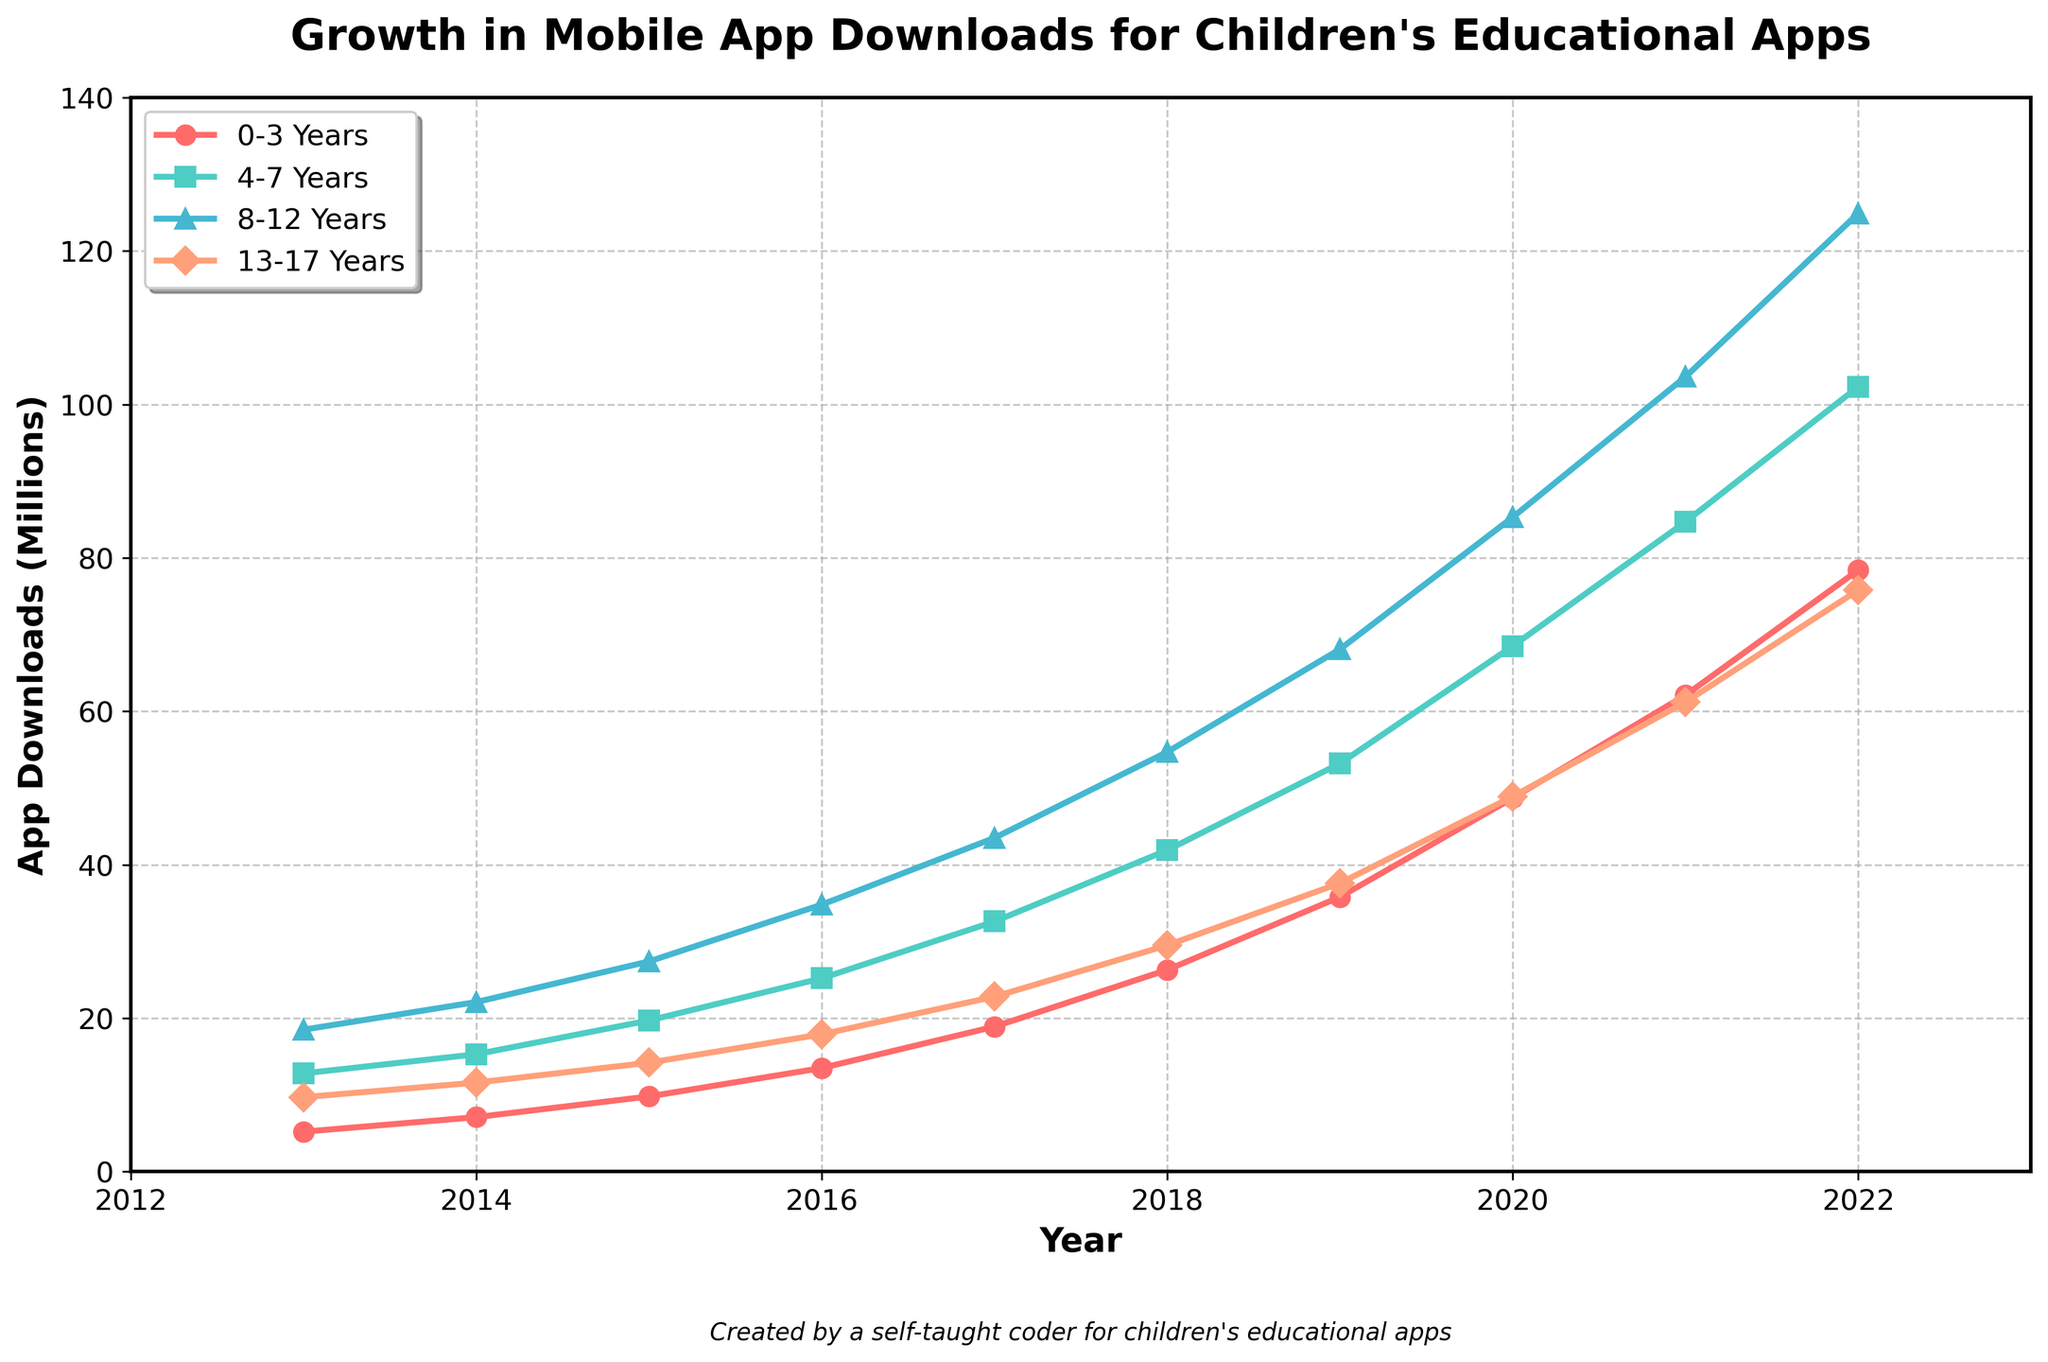What's the total download count for the 0-3 years age group across the years? To find the total download count for the 0-3 years age group, sum the values for each year: 5.2 + 7.1 + 9.8 + 13.5 + 18.9 + 26.3 + 35.8 + 48.7 + 62.1 + 78.4 = 305.8 million
Answer: 305.8 million In which year did the 8-12 years age group surpass 50 million downloads? Check the values for the 8-12 years age group until you find the year where the count first exceeds 50 million. In 2018, the downloads are 54.7 million.
Answer: 2018 Which age group had the highest number of downloads in 2016? Compare the download values for all age groups in 2016: 0-3 Years (13.5), 4-7 Years (25.2), 8-12 Years (34.8), 13-17 Years (17.9). The highest is for age group 8-12 Years.
Answer: 8-12 Years How does the download trend for the 13-17 years age group compare to the 0-3 years age group? Compare the trends by looking at the slopes of the lines. The download count for the 13-17 years age group increases consistently, but at a slower rate compared to the sharper and faster increase for the 0-3 years age group.
Answer: Slower but consistent By how much did the 4-7 years age group's downloads increase from 2013 to 2022? Subtract the 2013 download value from the 2022 value for the 4-7 years age group: 102.3 - 12.8 = 89.5 million
Answer: 89.5 million Which age group saw the most rapid growth in downloads from 2015 to 2020? Calculate the increase for each age group between 2015 and 2020: 
0-3 Years: 48.7 - 9.8 = 38.9 million, 
4-7 Years: 68.5 - 19.7 = 48.8 million, 
8-12 Years: 85.3 - 27.4 = 57.9 million, 
13-17 Years: 48.9 - 14.2 = 34.7 million.
The most significant growth is for the 8-12 years age group.
Answer: 8-12 Years In 2019, what was the download difference between the 0-3 years age group and the 13-17 years age group? Subtract the 13-17 years download count from the 0-3 years count for 2019: 35.8 - 37.6 = -1.8 million
Answer: -1.8 million What trend can be observed for the 4-7 years age group over the decade? Visually, the 4-7 years age group shows rapid and consistent growth in app downloads, with a steady increase each year from 12.8 million in 2013 to 102.3 million in 2022.
Answer: Rapid and consistent growth What's the average number of downloads for the 8-12 years age group over the entire period? Sum the download values for the 8-12 years age group and divide by the number of years: (18.5 + 22.1 + 27.4 + 34.8 + 43.5 + 54.7 + 68.1 + 85.3 + 103.6 + 124.9) / 10 = 58.29 million
Answer: 58.29 million By how much did the total downloads for all age groups increase from 2013 to 2017? Calculate the total downloads for all age groups in 2013 and 2017, then find the difference. 
2013: 5.2 + 12.8 + 18.5 + 9.7 = 46.2 million, 
2017: 18.9 + 32.6 + 43.5 + 22.8 = 117.8 million, 
Difference: 117.8 - 46.2 = 71.6 million
Answer: 71.6 million 